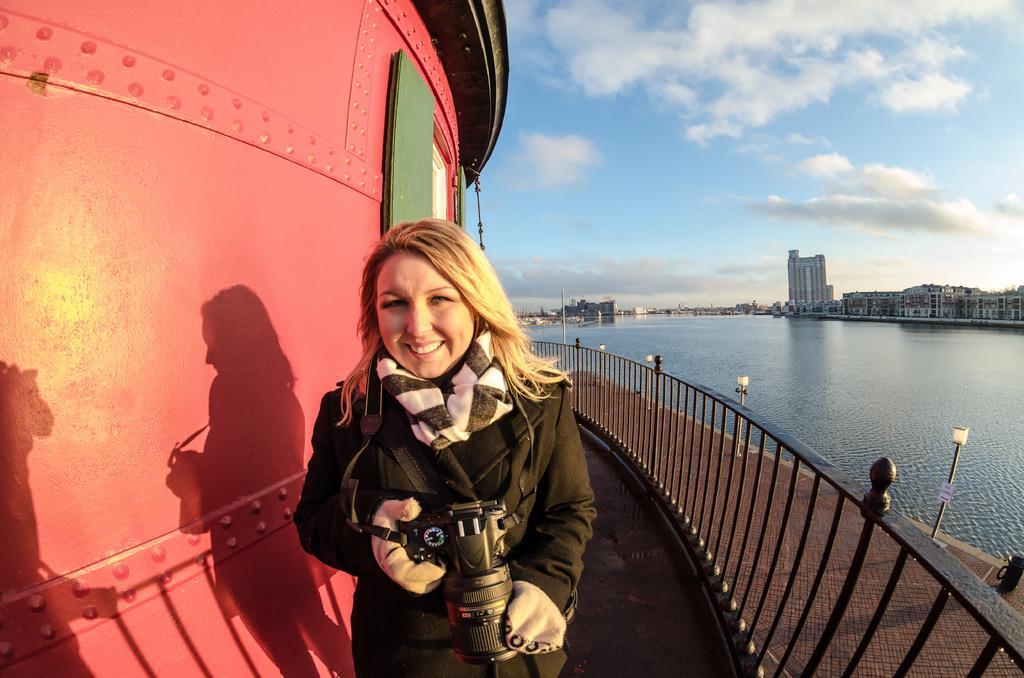Could you give a brief overview of what you see in this image? In the foreground of the image we can see a woman holding camera in her hands standing on the ground. On the right side of the image we can see a railing group of lights and water. On the left side of the image we can see a building with windows. In the background, we can see a group of buildings and the cloudy sky. 